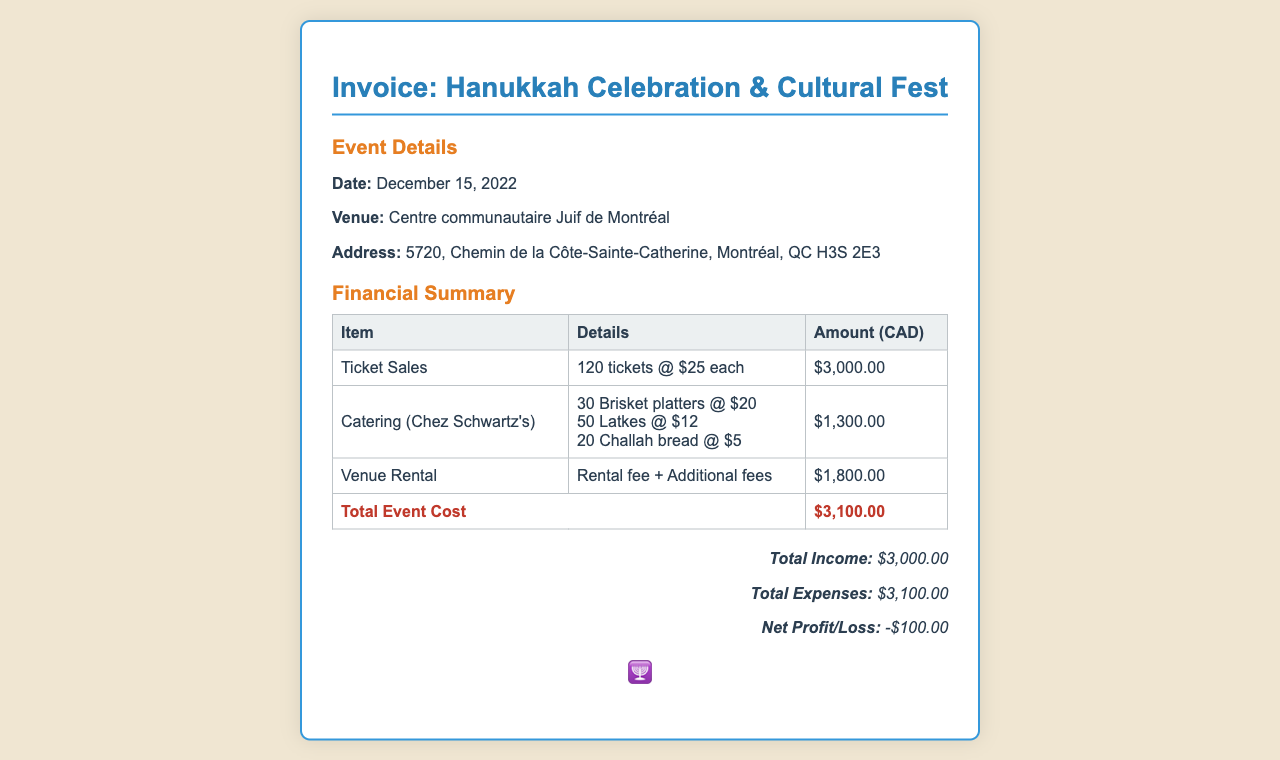what date was the event held? The event was held on December 15, 2022, which is specified in the event details section of the document.
Answer: December 15, 2022 what is the total expenses amount? The total expenses amount is given in the financial summary section as the total event cost.
Answer: $3,100.00 how much did the venue rental cost? The venue rental cost is mentioned in the table under the item "Venue Rental" in the financial summary.
Answer: $1,800.00 how many tickets were sold? The number of tickets sold is indicated as 120 tickets in the ticket sales description.
Answer: 120 what was the net profit or loss of the event? The net profit or loss is calculated and shown in the profit-loss section at the bottom of the invoice.
Answer: -$100.00 what catering service was used for the event? The catering service is specified in the financial summary table under the catering item.
Answer: Chez Schwartz's how many brisket platters were ordered? The number of brisket platters ordered is detailed in the catering expense breakdown.
Answer: 30 what was the total income from ticket sales? The total income figure from ticket sales is mentioned in the profit-loss section.
Answer: $3,000.00 